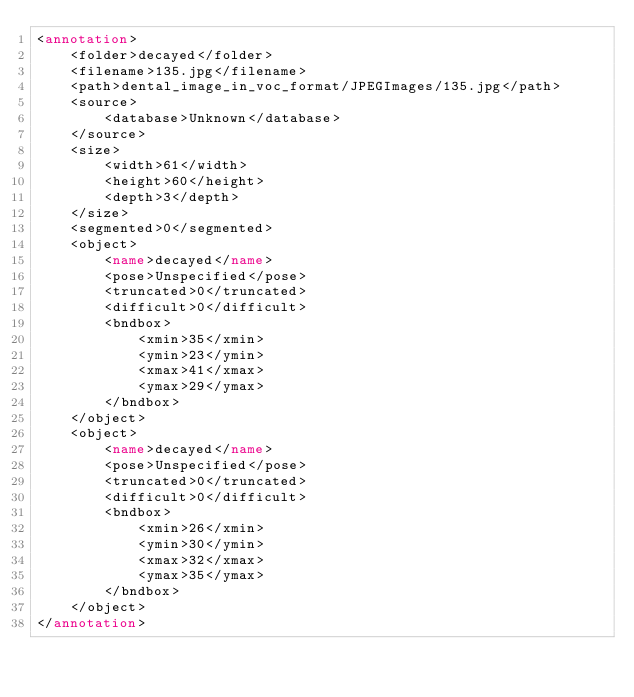Convert code to text. <code><loc_0><loc_0><loc_500><loc_500><_XML_><annotation>
	<folder>decayed</folder>
	<filename>135.jpg</filename>
	<path>dental_image_in_voc_format/JPEGImages/135.jpg</path>
	<source>
		<database>Unknown</database>
	</source>
	<size>
		<width>61</width>
		<height>60</height>
		<depth>3</depth>
	</size>
	<segmented>0</segmented>
	<object>
		<name>decayed</name>
		<pose>Unspecified</pose>
		<truncated>0</truncated>
		<difficult>0</difficult>
		<bndbox>
			<xmin>35</xmin>
			<ymin>23</ymin>
			<xmax>41</xmax>
			<ymax>29</ymax>
		</bndbox>
	</object>
	<object>
		<name>decayed</name>
		<pose>Unspecified</pose>
		<truncated>0</truncated>
		<difficult>0</difficult>
		<bndbox>
			<xmin>26</xmin>
			<ymin>30</ymin>
			<xmax>32</xmax>
			<ymax>35</ymax>
		</bndbox>
	</object>
</annotation>
</code> 